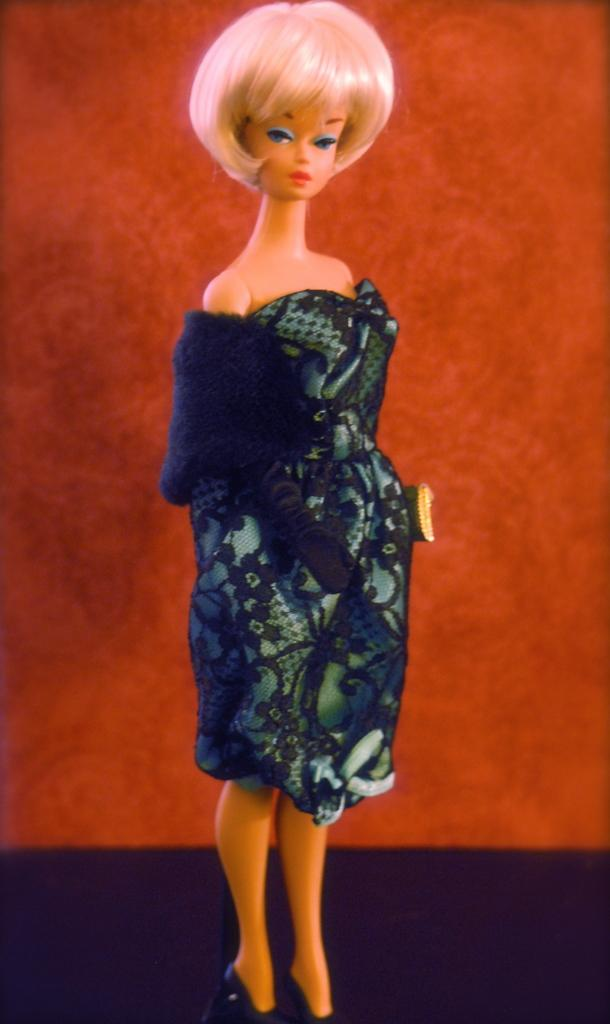What is the main subject in the center of the image? There is a doll in the center of the image. What can be seen in the background of the image? There is a wall visible in the background of the image. What type of quince is the mother writing about in the image? There is no mother or writing present in the image, and no mention of quince. 